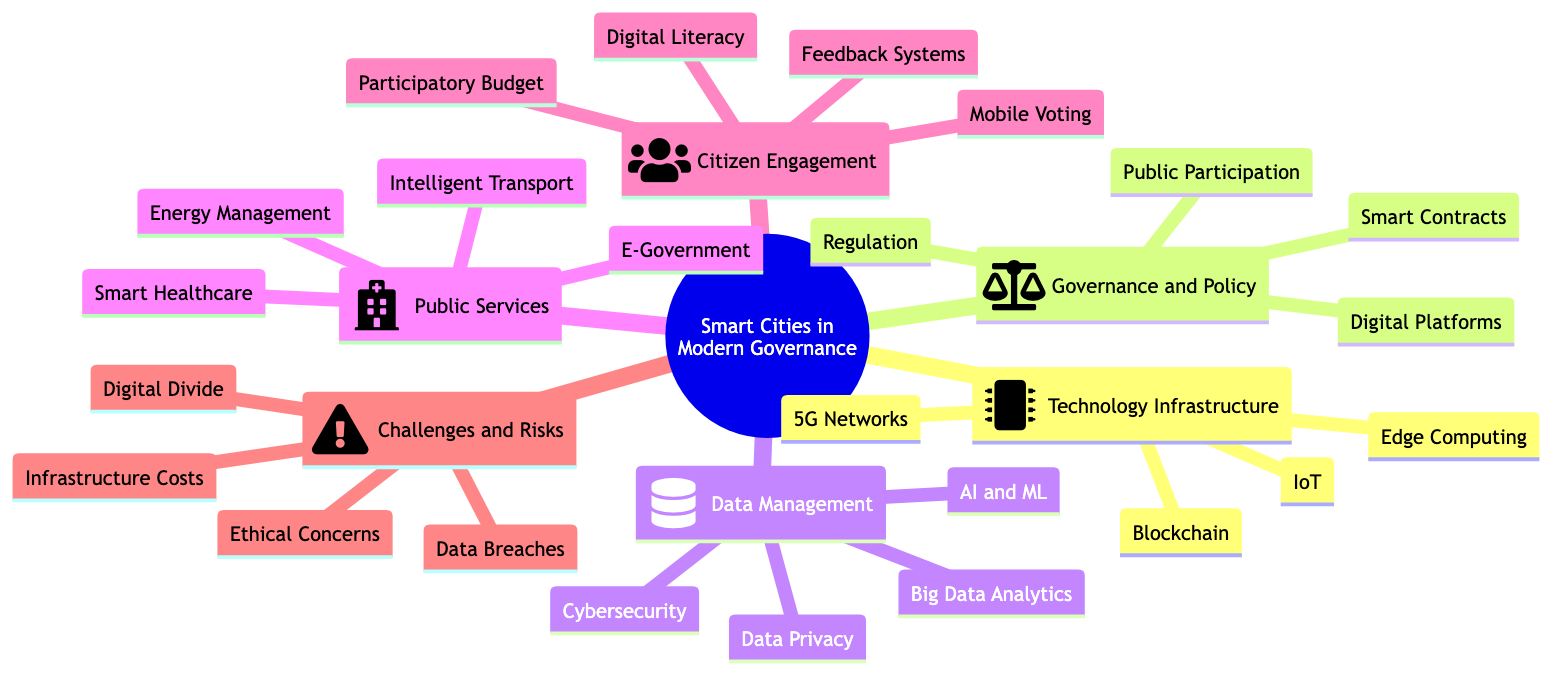What is the main topic of the mind map? The main topic is labeled at the root of the diagram, which focuses on the role of smart cities in modern governance.
Answer: The Role of Smart Cities in Modern Governance How many subtopics are under the main topic? By counting the visible subtopics connected to the main topic, we find six distinct categories: Technology Infrastructure, Governance and Policy, Data Management and Security, Public Services, Citizen Engagement, and Challenges and Risks.
Answer: Six What element belongs to the "Governance and Policy" subtopic? The subtopic "Governance and Policy" has specific elements branching from it; one example is "Digital Governance Platforms."
Answer: Digital Governance Platforms Which subtopic includes "Smart Healthcare"? The element "Smart Healthcare" is represented as part of the "Public Services" subtopic in the diagram.
Answer: Public Services What are two elements included in the "Citizen Engagement" subtopic? Under the "Citizen Engagement" subtopic, there are several elements listed; two examples are "Mobile Voting Apps" and "Community Feedback Systems."
Answer: Mobile Voting Apps, Community Feedback Systems How many elements are listed under "Data Management and Security"? The "Data Management and Security" subtopic contains four elements, which are "Big Data Analytics," "AI and Machine Learning," "Cybersecurity Measures," and "Data Privacy Policies."
Answer: Four What challenge is associated with smart cities, according to the mind map? The "Challenges and Risks" subtopic identifies several challenges, including "Data Breaches," which is a significant concern in smart cities.
Answer: Data Breaches Which topic is related to "Blockchain"? In the mind map, "Blockchain" is an element found within the "Technology Infrastructure" subtopic.
Answer: Technology Infrastructure What is the connection between "Regulation and Compliance" and governance in smart cities? "Regulation and Compliance" is one of the key elements in the "Governance and Policy" subtopic, indicating its importance for establishing rules within smart city governance.
Answer: Governance and Policy 